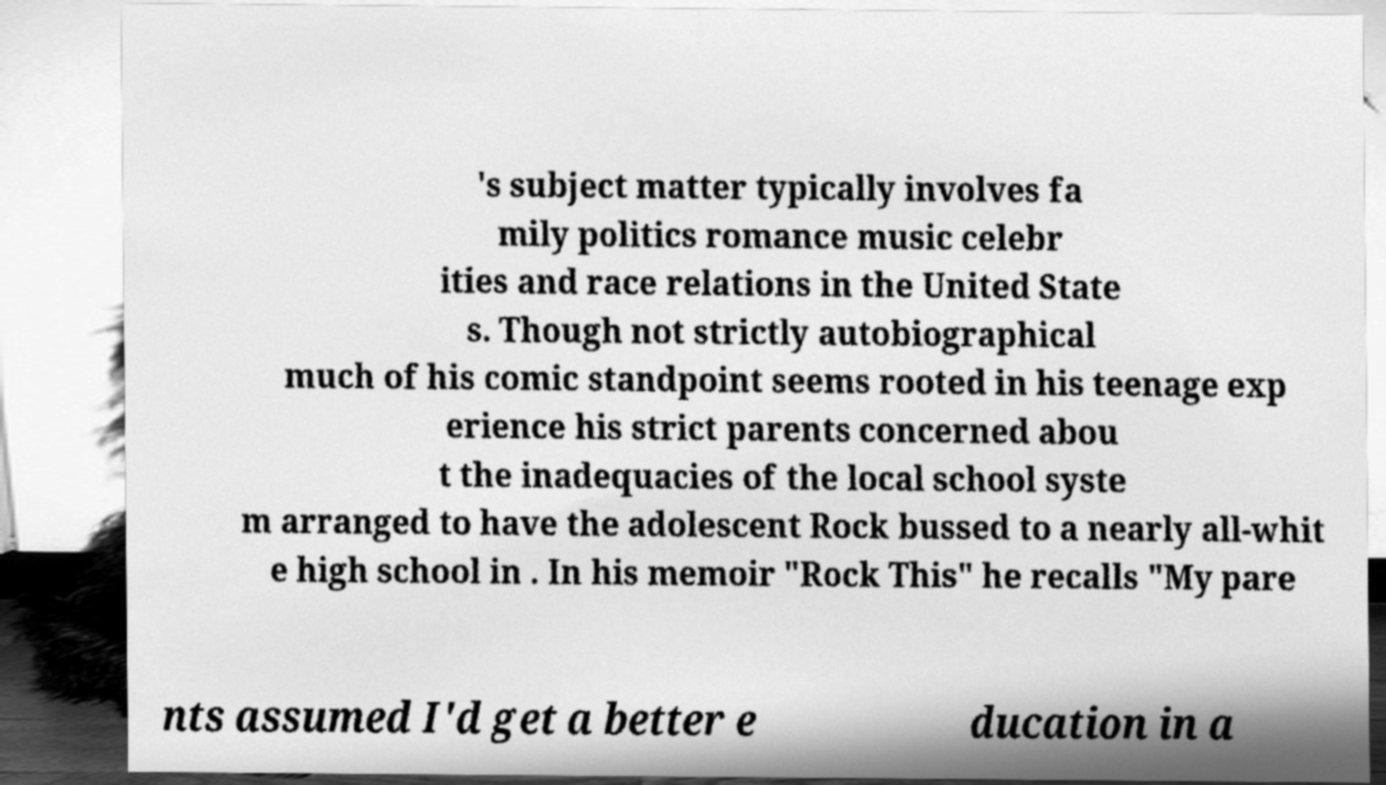What messages or text are displayed in this image? I need them in a readable, typed format. 's subject matter typically involves fa mily politics romance music celebr ities and race relations in the United State s. Though not strictly autobiographical much of his comic standpoint seems rooted in his teenage exp erience his strict parents concerned abou t the inadequacies of the local school syste m arranged to have the adolescent Rock bussed to a nearly all-whit e high school in . In his memoir "Rock This" he recalls "My pare nts assumed I'd get a better e ducation in a 